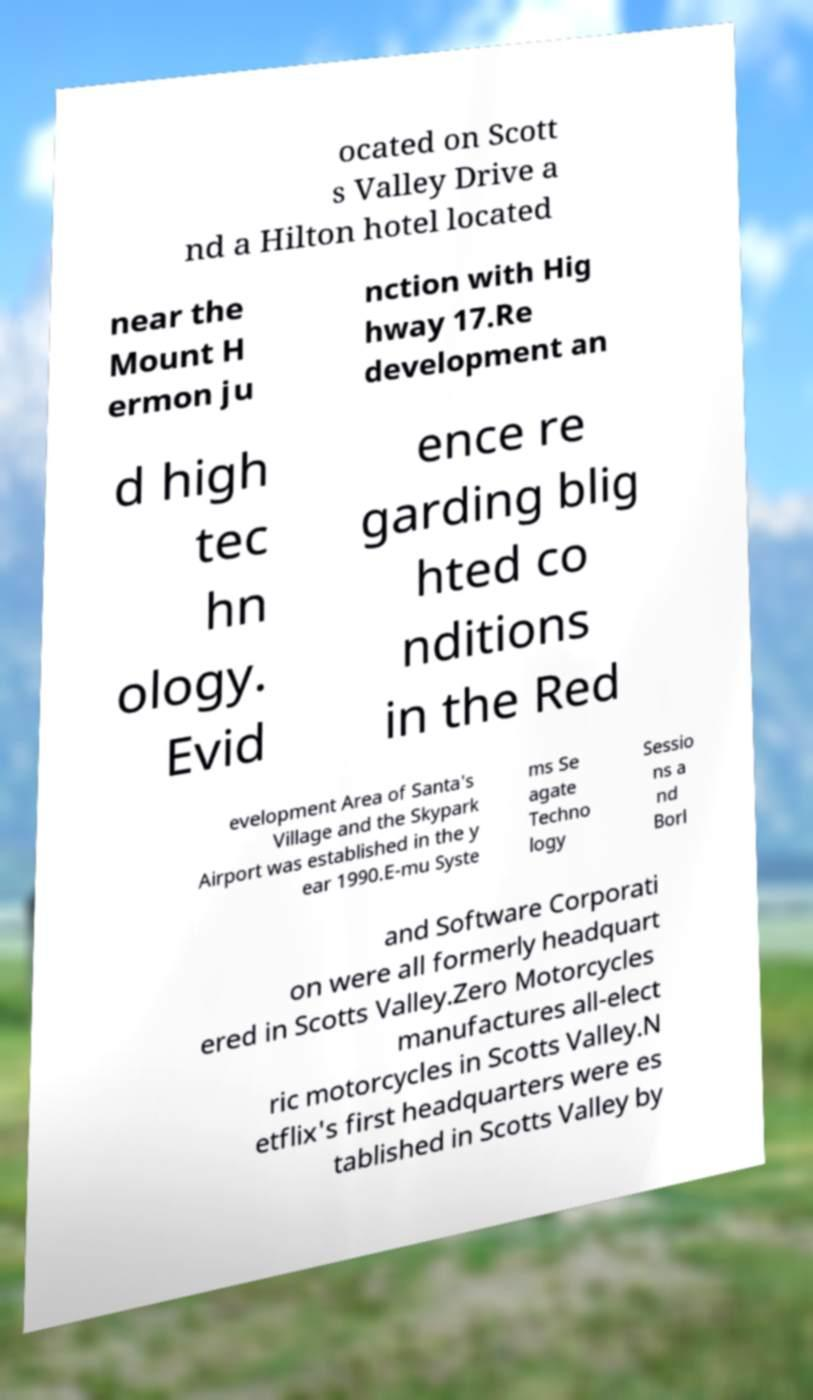Could you assist in decoding the text presented in this image and type it out clearly? ocated on Scott s Valley Drive a nd a Hilton hotel located near the Mount H ermon ju nction with Hig hway 17.Re development an d high tec hn ology. Evid ence re garding blig hted co nditions in the Red evelopment Area of Santa's Village and the Skypark Airport was established in the y ear 1990.E-mu Syste ms Se agate Techno logy Sessio ns a nd Borl and Software Corporati on were all formerly headquart ered in Scotts Valley.Zero Motorcycles manufactures all-elect ric motorcycles in Scotts Valley.N etflix's first headquarters were es tablished in Scotts Valley by 